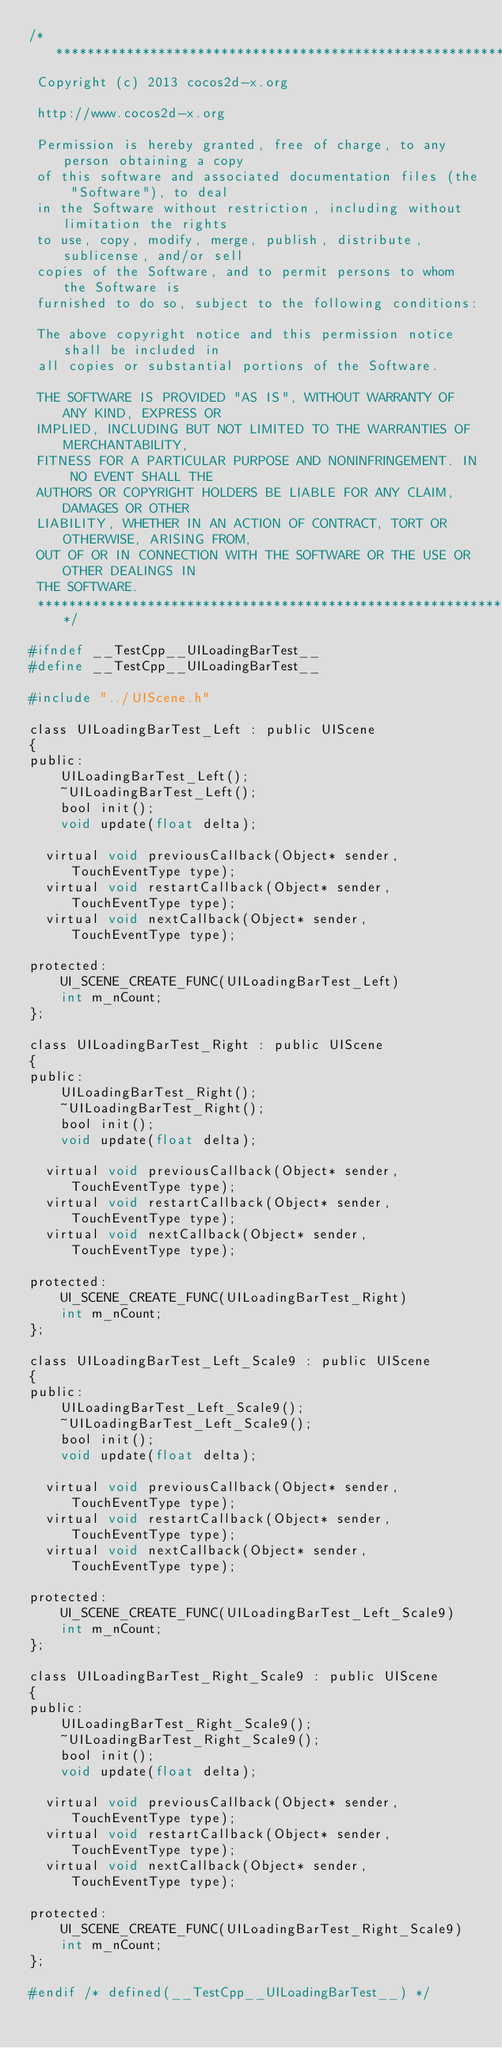Convert code to text. <code><loc_0><loc_0><loc_500><loc_500><_C_>/****************************************************************************
 Copyright (c) 2013 cocos2d-x.org
 
 http://www.cocos2d-x.org
 
 Permission is hereby granted, free of charge, to any person obtaining a copy
 of this software and associated documentation files (the "Software"), to deal
 in the Software without restriction, including without limitation the rights
 to use, copy, modify, merge, publish, distribute, sublicense, and/or sell
 copies of the Software, and to permit persons to whom the Software is
 furnished to do so, subject to the following conditions:
 
 The above copyright notice and this permission notice shall be included in
 all copies or substantial portions of the Software.
 
 THE SOFTWARE IS PROVIDED "AS IS", WITHOUT WARRANTY OF ANY KIND, EXPRESS OR
 IMPLIED, INCLUDING BUT NOT LIMITED TO THE WARRANTIES OF MERCHANTABILITY,
 FITNESS FOR A PARTICULAR PURPOSE AND NONINFRINGEMENT. IN NO EVENT SHALL THE
 AUTHORS OR COPYRIGHT HOLDERS BE LIABLE FOR ANY CLAIM, DAMAGES OR OTHER
 LIABILITY, WHETHER IN AN ACTION OF CONTRACT, TORT OR OTHERWISE, ARISING FROM,
 OUT OF OR IN CONNECTION WITH THE SOFTWARE OR THE USE OR OTHER DEALINGS IN
 THE SOFTWARE.
 ****************************************************************************/

#ifndef __TestCpp__UILoadingBarTest__
#define __TestCpp__UILoadingBarTest__

#include "../UIScene.h"

class UILoadingBarTest_Left : public UIScene
{
public:
    UILoadingBarTest_Left();
    ~UILoadingBarTest_Left();
    bool init();
    void update(float delta);

	virtual void previousCallback(Object* sender, TouchEventType type);
	virtual void restartCallback(Object* sender, TouchEventType type);
	virtual void nextCallback(Object* sender, TouchEventType type);
    
protected:
    UI_SCENE_CREATE_FUNC(UILoadingBarTest_Left)
    int m_nCount;
};

class UILoadingBarTest_Right : public UIScene
{
public:
    UILoadingBarTest_Right();
    ~UILoadingBarTest_Right();
    bool init();
    void update(float delta);

	virtual void previousCallback(Object* sender, TouchEventType type);
	virtual void restartCallback(Object* sender, TouchEventType type);
	virtual void nextCallback(Object* sender, TouchEventType type);
    
protected:
    UI_SCENE_CREATE_FUNC(UILoadingBarTest_Right)
    int m_nCount;
};

class UILoadingBarTest_Left_Scale9 : public UIScene
{
public:
    UILoadingBarTest_Left_Scale9();
    ~UILoadingBarTest_Left_Scale9();
    bool init();
    void update(float delta);

	virtual void previousCallback(Object* sender, TouchEventType type);
	virtual void restartCallback(Object* sender, TouchEventType type);
	virtual void nextCallback(Object* sender, TouchEventType type);
    
protected:
    UI_SCENE_CREATE_FUNC(UILoadingBarTest_Left_Scale9)
    int m_nCount;
};

class UILoadingBarTest_Right_Scale9 : public UIScene
{
public:
    UILoadingBarTest_Right_Scale9();
    ~UILoadingBarTest_Right_Scale9();
    bool init();
    void update(float delta);

	virtual void previousCallback(Object* sender, TouchEventType type);
	virtual void restartCallback(Object* sender, TouchEventType type);
	virtual void nextCallback(Object* sender, TouchEventType type);
    
protected:
    UI_SCENE_CREATE_FUNC(UILoadingBarTest_Right_Scale9)
    int m_nCount;
};

#endif /* defined(__TestCpp__UILoadingBarTest__) */
</code> 